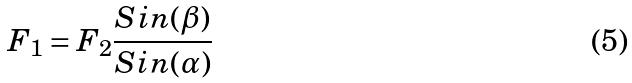Convert formula to latex. <formula><loc_0><loc_0><loc_500><loc_500>F _ { 1 } = F _ { 2 } \frac { S i n ( \beta ) } { S i n ( \alpha ) }</formula> 